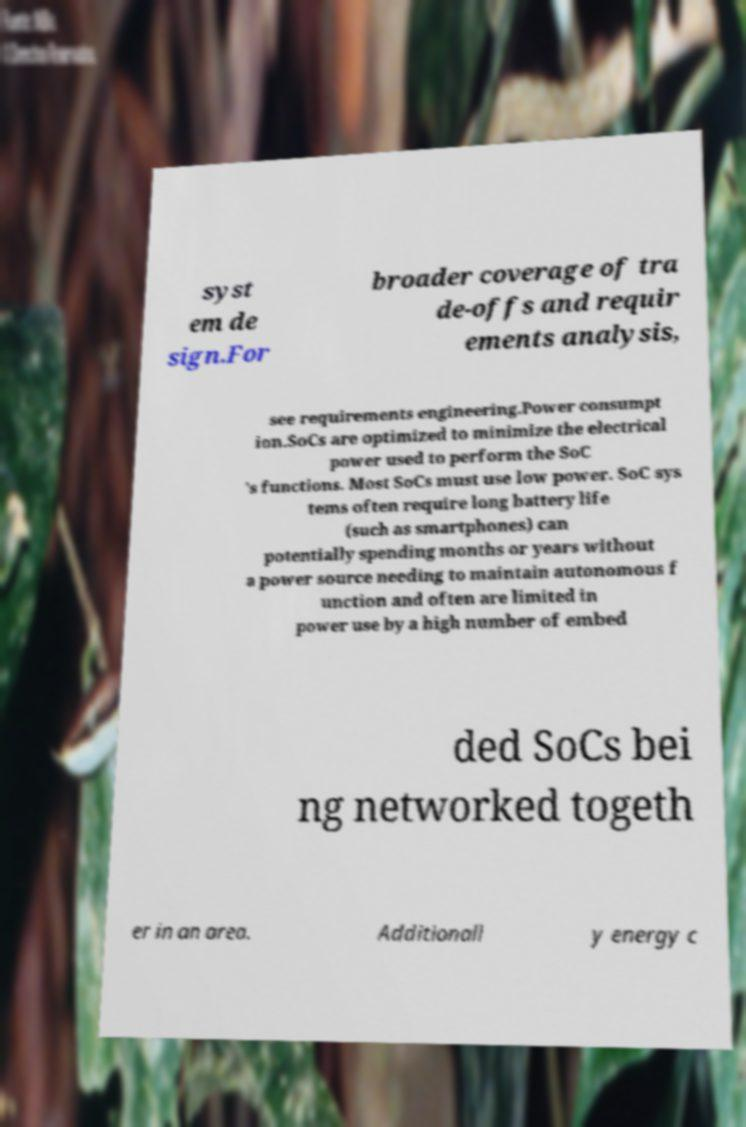Could you assist in decoding the text presented in this image and type it out clearly? syst em de sign.For broader coverage of tra de-offs and requir ements analysis, see requirements engineering.Power consumpt ion.SoCs are optimized to minimize the electrical power used to perform the SoC 's functions. Most SoCs must use low power. SoC sys tems often require long battery life (such as smartphones) can potentially spending months or years without a power source needing to maintain autonomous f unction and often are limited in power use by a high number of embed ded SoCs bei ng networked togeth er in an area. Additionall y energy c 